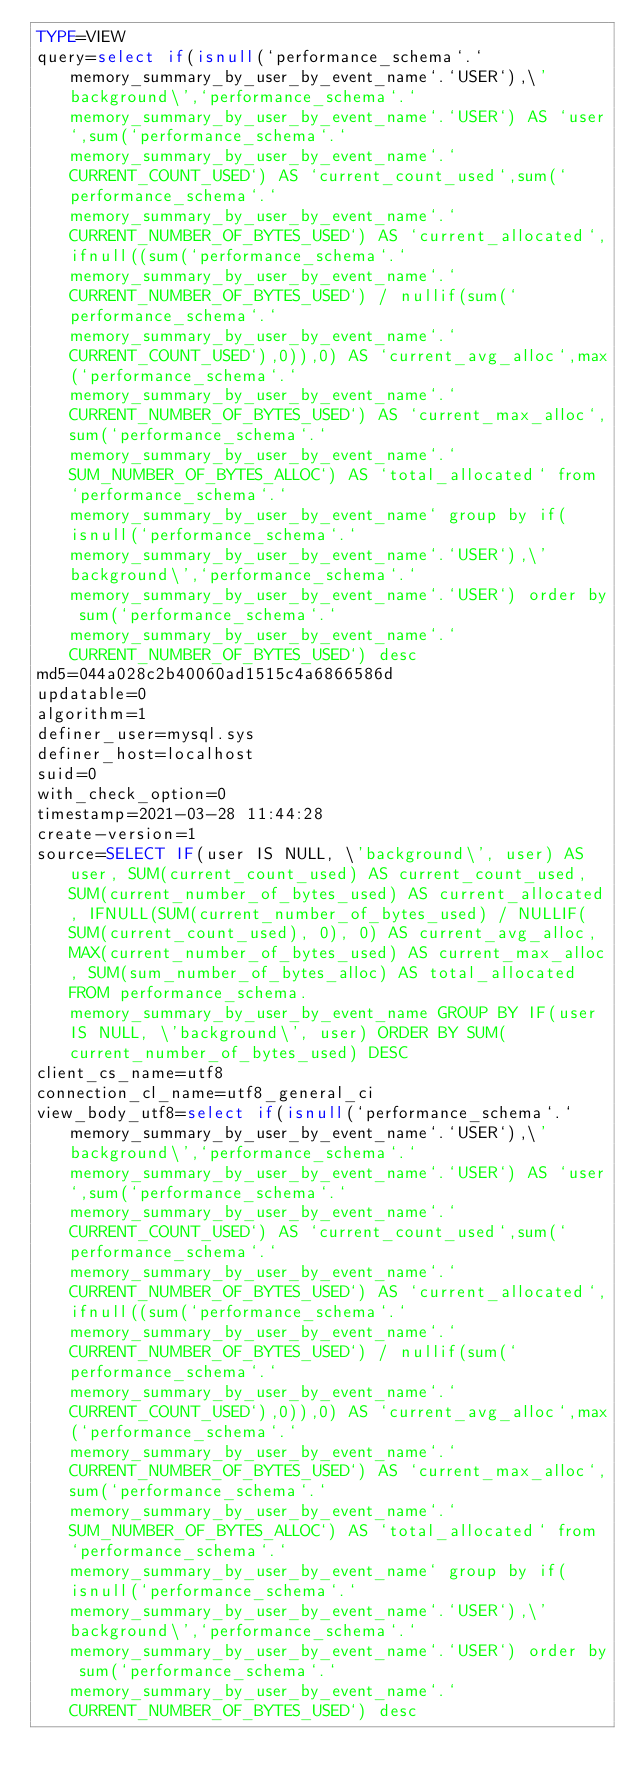Convert code to text. <code><loc_0><loc_0><loc_500><loc_500><_VisualBasic_>TYPE=VIEW
query=select if(isnull(`performance_schema`.`memory_summary_by_user_by_event_name`.`USER`),\'background\',`performance_schema`.`memory_summary_by_user_by_event_name`.`USER`) AS `user`,sum(`performance_schema`.`memory_summary_by_user_by_event_name`.`CURRENT_COUNT_USED`) AS `current_count_used`,sum(`performance_schema`.`memory_summary_by_user_by_event_name`.`CURRENT_NUMBER_OF_BYTES_USED`) AS `current_allocated`,ifnull((sum(`performance_schema`.`memory_summary_by_user_by_event_name`.`CURRENT_NUMBER_OF_BYTES_USED`) / nullif(sum(`performance_schema`.`memory_summary_by_user_by_event_name`.`CURRENT_COUNT_USED`),0)),0) AS `current_avg_alloc`,max(`performance_schema`.`memory_summary_by_user_by_event_name`.`CURRENT_NUMBER_OF_BYTES_USED`) AS `current_max_alloc`,sum(`performance_schema`.`memory_summary_by_user_by_event_name`.`SUM_NUMBER_OF_BYTES_ALLOC`) AS `total_allocated` from `performance_schema`.`memory_summary_by_user_by_event_name` group by if(isnull(`performance_schema`.`memory_summary_by_user_by_event_name`.`USER`),\'background\',`performance_schema`.`memory_summary_by_user_by_event_name`.`USER`) order by sum(`performance_schema`.`memory_summary_by_user_by_event_name`.`CURRENT_NUMBER_OF_BYTES_USED`) desc
md5=044a028c2b40060ad1515c4a6866586d
updatable=0
algorithm=1
definer_user=mysql.sys
definer_host=localhost
suid=0
with_check_option=0
timestamp=2021-03-28 11:44:28
create-version=1
source=SELECT IF(user IS NULL, \'background\', user) AS user, SUM(current_count_used) AS current_count_used, SUM(current_number_of_bytes_used) AS current_allocated, IFNULL(SUM(current_number_of_bytes_used) / NULLIF(SUM(current_count_used), 0), 0) AS current_avg_alloc, MAX(current_number_of_bytes_used) AS current_max_alloc, SUM(sum_number_of_bytes_alloc) AS total_allocated FROM performance_schema.memory_summary_by_user_by_event_name GROUP BY IF(user IS NULL, \'background\', user) ORDER BY SUM(current_number_of_bytes_used) DESC
client_cs_name=utf8
connection_cl_name=utf8_general_ci
view_body_utf8=select if(isnull(`performance_schema`.`memory_summary_by_user_by_event_name`.`USER`),\'background\',`performance_schema`.`memory_summary_by_user_by_event_name`.`USER`) AS `user`,sum(`performance_schema`.`memory_summary_by_user_by_event_name`.`CURRENT_COUNT_USED`) AS `current_count_used`,sum(`performance_schema`.`memory_summary_by_user_by_event_name`.`CURRENT_NUMBER_OF_BYTES_USED`) AS `current_allocated`,ifnull((sum(`performance_schema`.`memory_summary_by_user_by_event_name`.`CURRENT_NUMBER_OF_BYTES_USED`) / nullif(sum(`performance_schema`.`memory_summary_by_user_by_event_name`.`CURRENT_COUNT_USED`),0)),0) AS `current_avg_alloc`,max(`performance_schema`.`memory_summary_by_user_by_event_name`.`CURRENT_NUMBER_OF_BYTES_USED`) AS `current_max_alloc`,sum(`performance_schema`.`memory_summary_by_user_by_event_name`.`SUM_NUMBER_OF_BYTES_ALLOC`) AS `total_allocated` from `performance_schema`.`memory_summary_by_user_by_event_name` group by if(isnull(`performance_schema`.`memory_summary_by_user_by_event_name`.`USER`),\'background\',`performance_schema`.`memory_summary_by_user_by_event_name`.`USER`) order by sum(`performance_schema`.`memory_summary_by_user_by_event_name`.`CURRENT_NUMBER_OF_BYTES_USED`) desc
</code> 